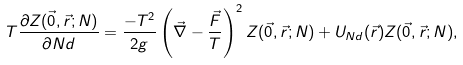<formula> <loc_0><loc_0><loc_500><loc_500>T \frac { \partial Z ( \vec { 0 } , \vec { r } ; N ) } { \partial N d } = \frac { - T ^ { 2 } } { 2 g } \left ( \vec { \nabla } - \frac { \vec { F } } { T } \right ) ^ { 2 } Z ( \vec { 0 } , \vec { r } ; N ) + U _ { N d } ( \vec { r } ) Z ( \vec { 0 } , \vec { r } ; N ) ,</formula> 